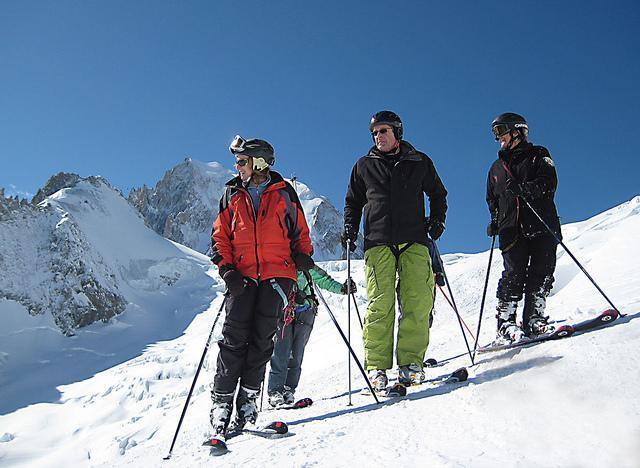What are they ready to do here?
Pick the right solution, then justify: 'Answer: answer
Rationale: rationale.'
Options: Descend, cross, ascend, retreat. Answer: descend.
Rationale: Once a skier is at the top of the mountain, there is nothing else to do but ski down. 